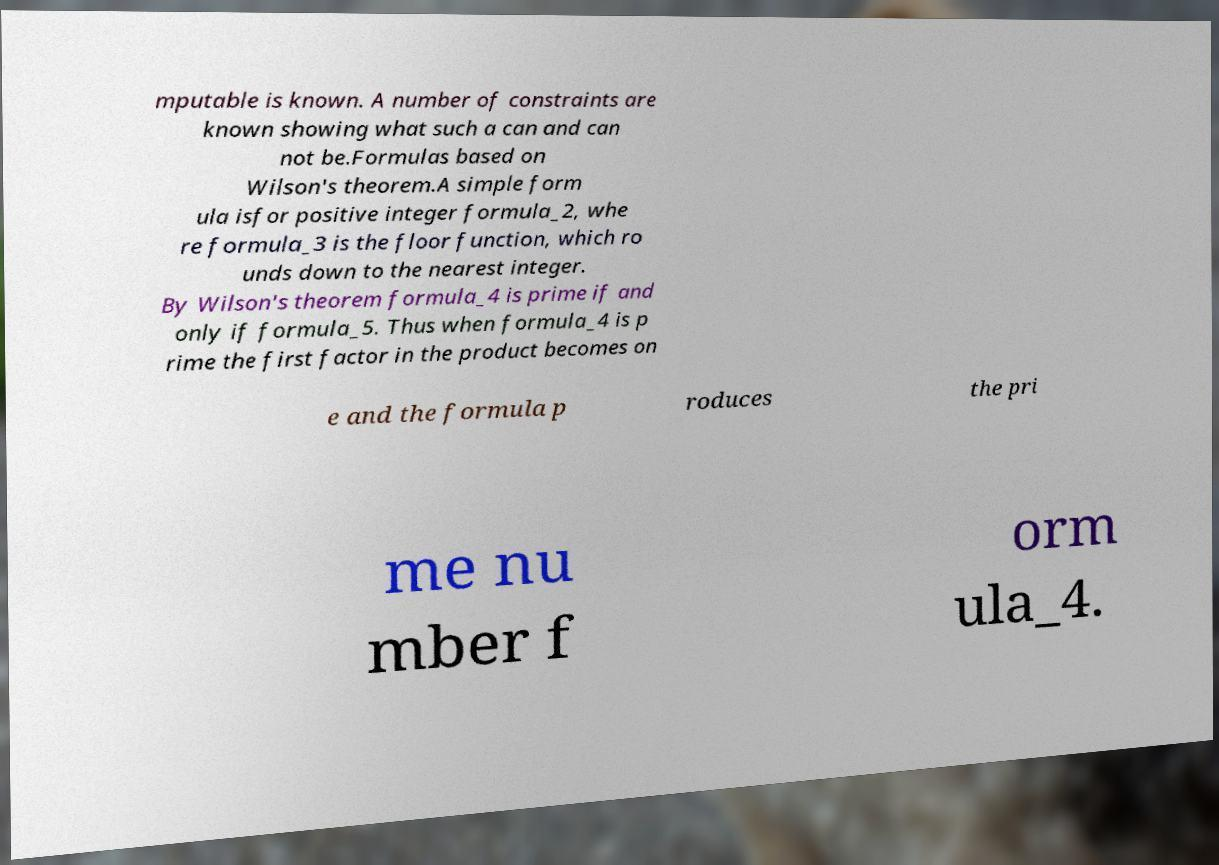Please read and relay the text visible in this image. What does it say? mputable is known. A number of constraints are known showing what such a can and can not be.Formulas based on Wilson's theorem.A simple form ula isfor positive integer formula_2, whe re formula_3 is the floor function, which ro unds down to the nearest integer. By Wilson's theorem formula_4 is prime if and only if formula_5. Thus when formula_4 is p rime the first factor in the product becomes on e and the formula p roduces the pri me nu mber f orm ula_4. 